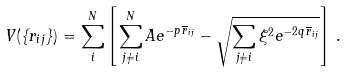<formula> <loc_0><loc_0><loc_500><loc_500>V ( \{ r _ { i j } \} ) = \sum _ { i } ^ { N } \left [ \sum _ { j \neq i } ^ { N } A e ^ { - p \, \overline { r } _ { i j } } - \sqrt { \sum _ { j \neq i } \xi ^ { 2 } e ^ { - 2 q \, \overline { r } _ { i j } } } \right ] \, .</formula> 